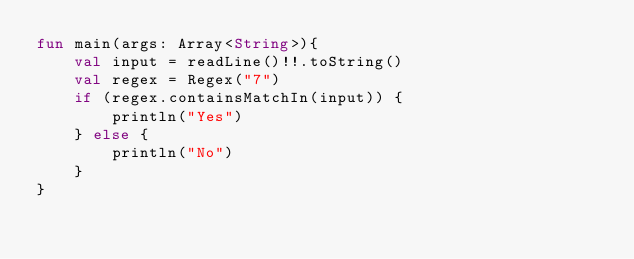<code> <loc_0><loc_0><loc_500><loc_500><_Kotlin_>fun main(args: Array<String>){
    val input = readLine()!!.toString()
    val regex = Regex("7")
    if (regex.containsMatchIn(input)) {
        println("Yes")
    } else {
        println("No")
    }
}</code> 